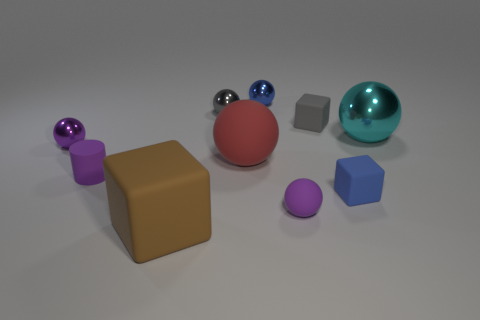The cylinder that is the same color as the small matte sphere is what size? Unfortunately, there's no cylinder present in the image that matches the color of any of the spheres—small or otherwise. What we have in the image are spheres, cubes, and a larger rectangular prism-like shape. Some objects are glossy while others have a matte finish, but no cylinders are visible. 